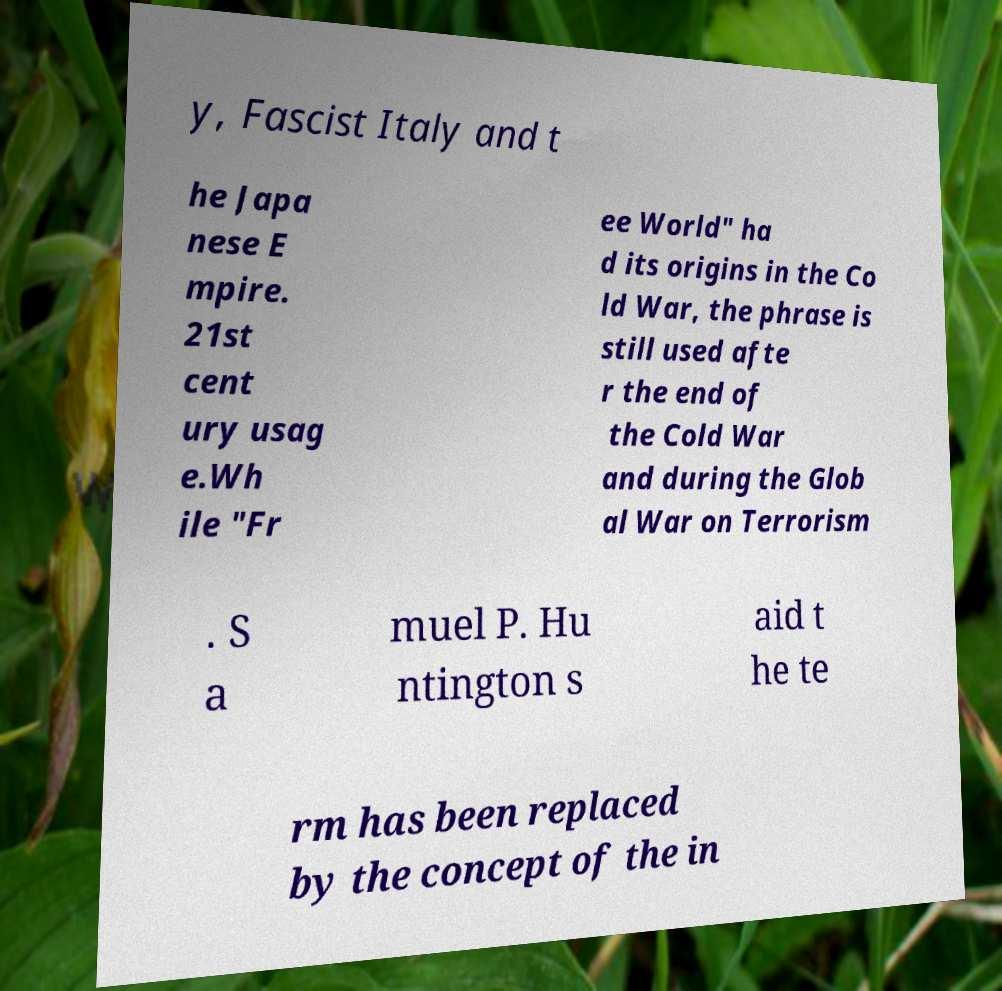What messages or text are displayed in this image? I need them in a readable, typed format. y, Fascist Italy and t he Japa nese E mpire. 21st cent ury usag e.Wh ile "Fr ee World" ha d its origins in the Co ld War, the phrase is still used afte r the end of the Cold War and during the Glob al War on Terrorism . S a muel P. Hu ntington s aid t he te rm has been replaced by the concept of the in 